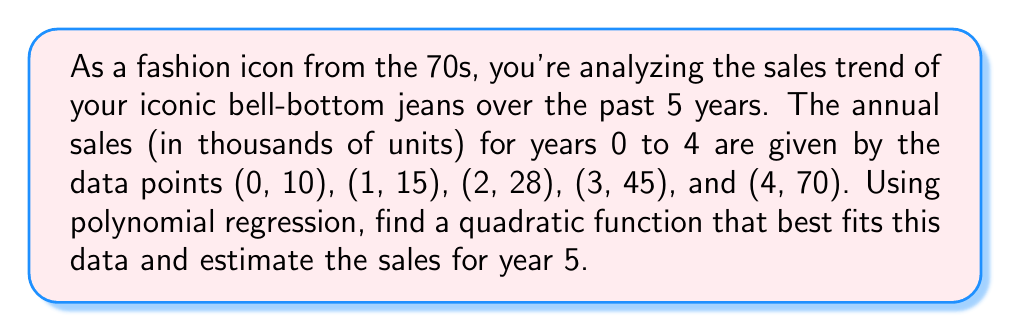Can you answer this question? To find the quadratic function that best fits the given data, we'll use the method of least squares for polynomial regression. Let's assume the function has the form:

$$f(x) = ax^2 + bx + c$$

Where $x$ represents the year (with year 0 being the first year) and $f(x)$ represents the sales in thousands of units.

Step 1: Set up the system of normal equations:
$$\begin{cases}
\sum y = an\sum x^2 + b\sum x + nc \\
\sum xy = a\sum x^3 + b\sum x^2 + c\sum x \\
\sum x^2y = a\sum x^4 + b\sum x^3 + c\sum x^2
\end{cases}$$

Step 2: Calculate the required sums:
$$\begin{aligned}
\sum x &= 0 + 1 + 2 + 3 + 4 = 10 \\
\sum x^2 &= 0^2 + 1^2 + 2^2 + 3^2 + 4^2 = 30 \\
\sum x^3 &= 0^3 + 1^3 + 2^3 + 3^3 + 4^3 = 100 \\
\sum x^4 &= 0^4 + 1^4 + 2^4 + 3^4 + 4^4 = 354 \\
\sum y &= 10 + 15 + 28 + 45 + 70 = 168 \\
\sum xy &= 0(10) + 1(15) + 2(28) + 3(45) + 4(70) = 506 \\
\sum x^2y &= 0^2(10) + 1^2(15) + 2^2(28) + 3^2(45) + 4^2(70) = 1620
\end{aligned}$$

Step 3: Substitute these values into the system of equations:
$$\begin{cases}
168 = 30a + 10b + 5c \\
506 = 100a + 30b + 10c \\
1620 = 354a + 100b + 30c
\end{cases}$$

Step 4: Solve this system of equations (using a calculator or computer algebra system):
$$\begin{aligned}
a &\approx 2.5 \\
b &\approx 2.5 \\
c &\approx 10
\end{aligned}$$

Step 5: Write the quadratic function:
$$f(x) = 2.5x^2 + 2.5x + 10$$

Step 6: Estimate the sales for year 5 by evaluating $f(5)$:
$$\begin{aligned}
f(5) &= 2.5(5^2) + 2.5(5) + 10 \\
&= 2.5(25) + 12.5 + 10 \\
&= 62.5 + 12.5 + 10 \\
&= 85
\end{aligned}$$

Therefore, the estimated sales for year 5 are 85 thousand units.
Answer: The quadratic function that best fits the data is $f(x) = 2.5x^2 + 2.5x + 10$, and the estimated sales for year 5 are 85 thousand units. 